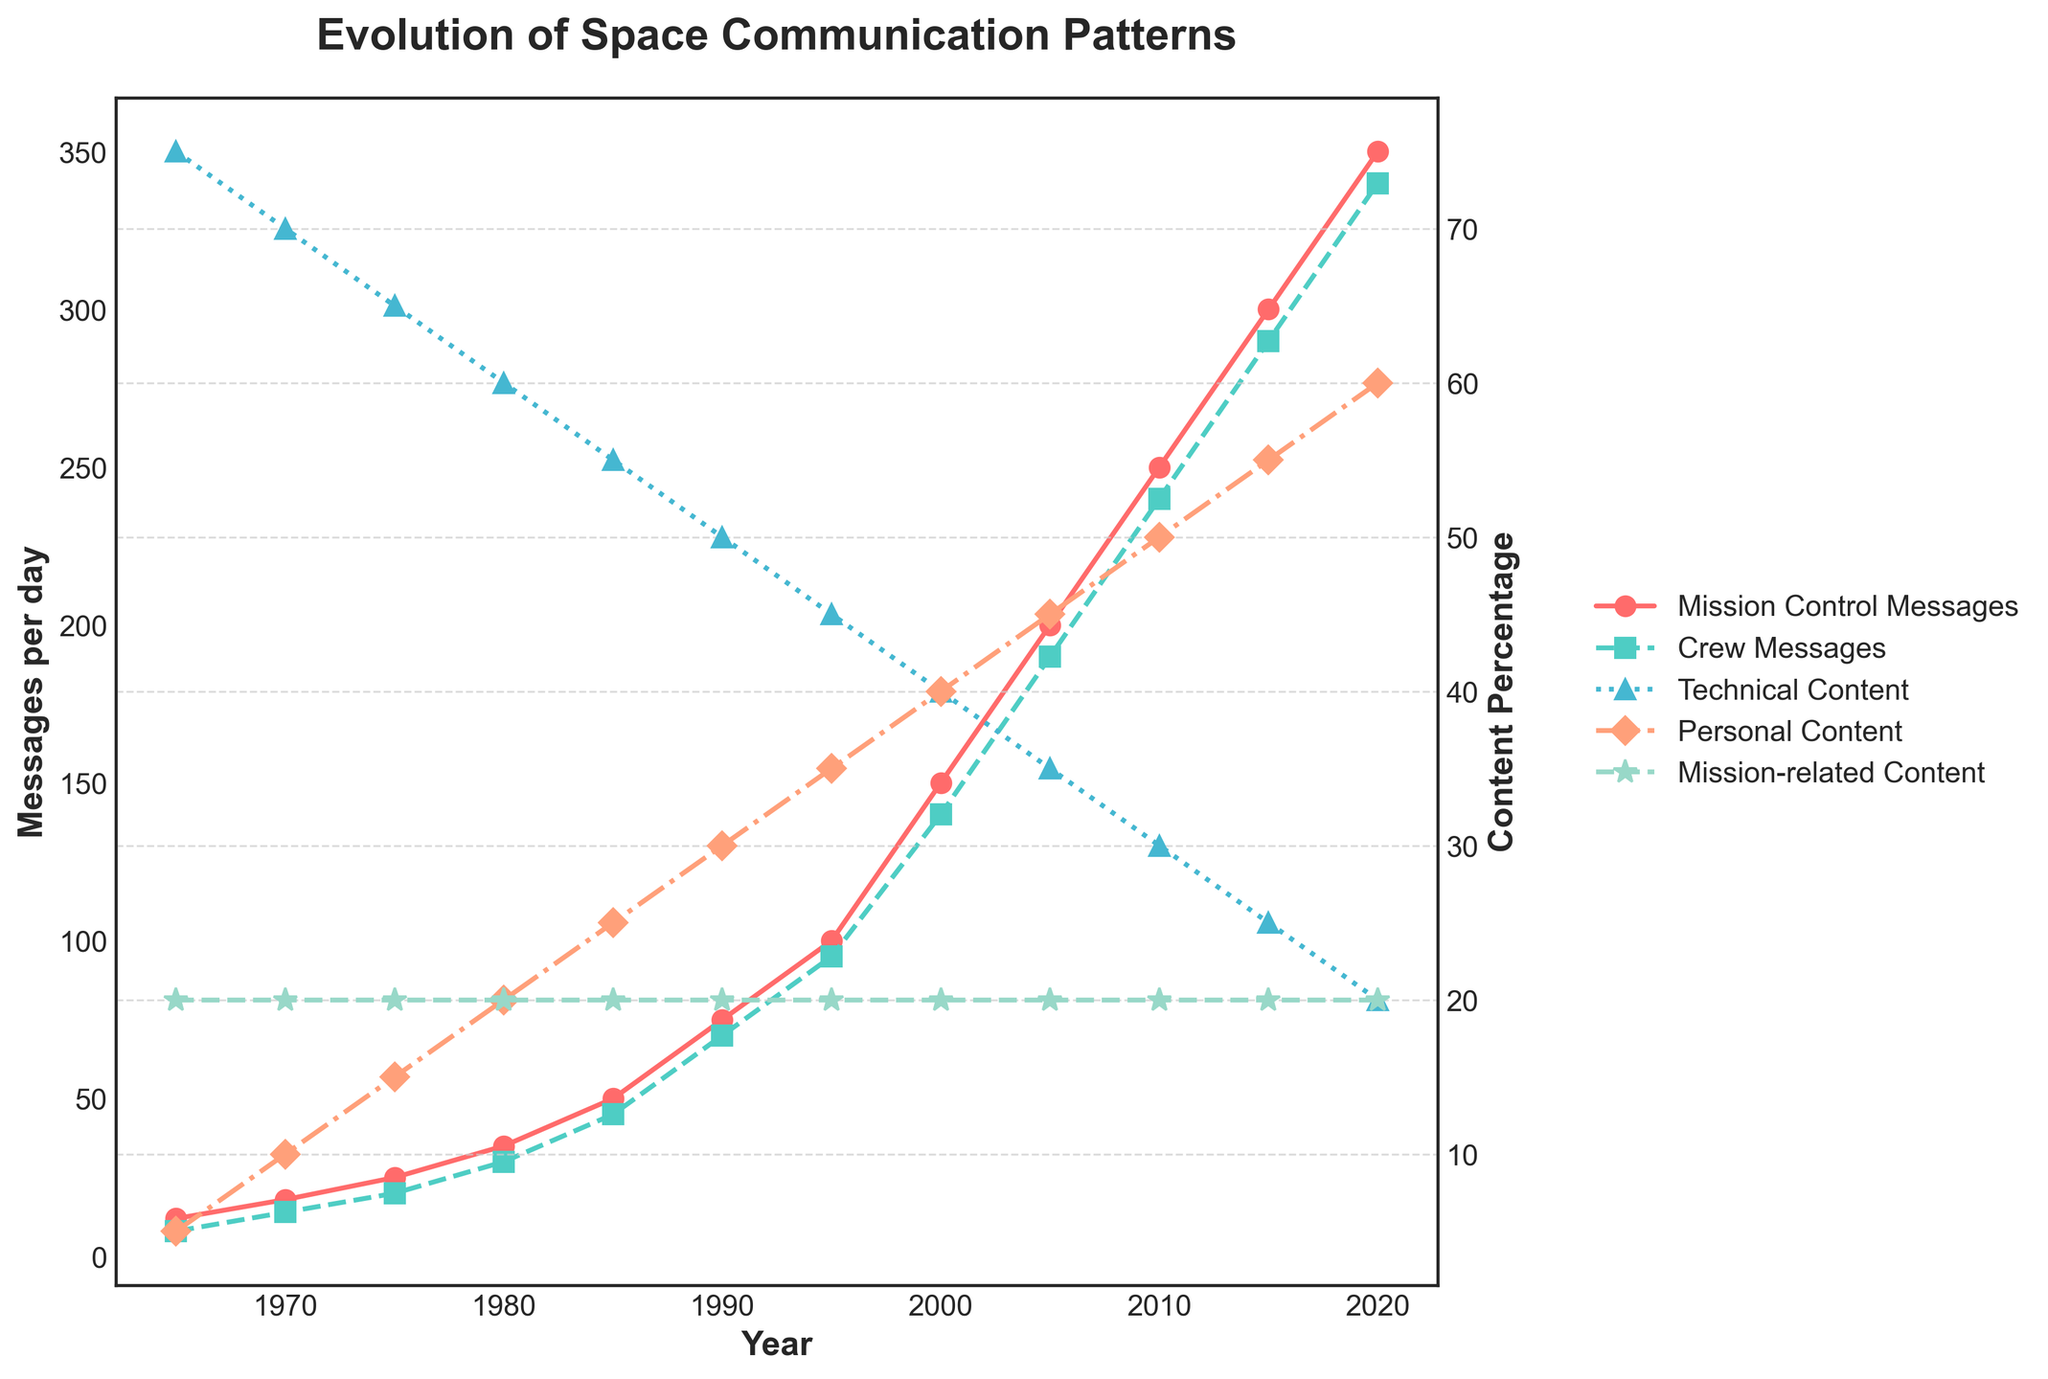What is the trend in Mission Control Messages per day from 1965 to 2020? Looking at the red line with circle markers representing Mission Control Messages per day, it shows a consistent increase from 1965 to 2020. This trend indicates that the number of messages per day has been steadily rising over the years.
Answer: Increasing How do the trends of Mission Control Messages and Crew Messages per day compare? Both the red line with circle markers (Mission Control Messages) and the green line with square markers (Crew Messages) show a similar increasing trend. This indicates that both Mission Control and Crew Messages per day have been increasing over the years, with Mission Control usually having higher values.
Answer: Both increasing, Mission Control higher Which year had the highest percentage of Personal Content in messages? Looking at the orange line with diamond markers representing Personal Content (%), the highest percentage is in 2020. This is the final point on the graph where the Personal Content percentage reaches its peak.
Answer: 2020 What is the difference between Mission Control Messages and Crew Messages per day in 1980? For 1980, the red line with circle markers (Mission Control Messages) is at 35, and the green line with square markers (Crew Messages) is at 30. Subtracting these values gives us 35 - 30 = 5.
Answer: 5 What patterns can be observed in Technical Content over time? Observing the blue line with triangular markers representing Technical Content (%), it shows a consistent decline from 1965 to 2020. The percentage dropped from 75% in 1965 to 20% in 2020.
Answer: Decreasing Compare the percentage of Mission-related Content over the years. The greenish-blue line with star markers representing Mission-related Content (%) remains constant at 20% throughout the entire timeline. There is no change observed in this category.
Answer: Constant Which year marked the highest difference in message frequency between Mission Control and Crew? In 2020, the difference between Mission Control Messages (350) and Crew Messages (340) is the largest at 10, as compared to other years.
Answer: 2020 How has the balance between Technical Content and Personal Content in messages changed over time? Initially, in 1965, Technical Content (75%) vastly outweighed Personal Content (5%). Over the years, Technical Content steadily declined, while Personal Content steadily increased. By 2020, Personal Content (60%) surpassed Technical Content (20%).
Answer: Technical decreased, Personal increased What is the sum of Personal Content percentages in the years 1985 and 2000? For 1985, the Personal Content percentage is 25%, and for 2000, it is 40%. Summing them up, 25 + 40 = 65.
Answer: 65 Which content type has remained steady throughout the whole period? The greenish-blue line with star markers indicating Mission-related Content (%) remains steady at 20% from 1965 to 2020, without any fluctuation.
Answer: Mission-related Content 